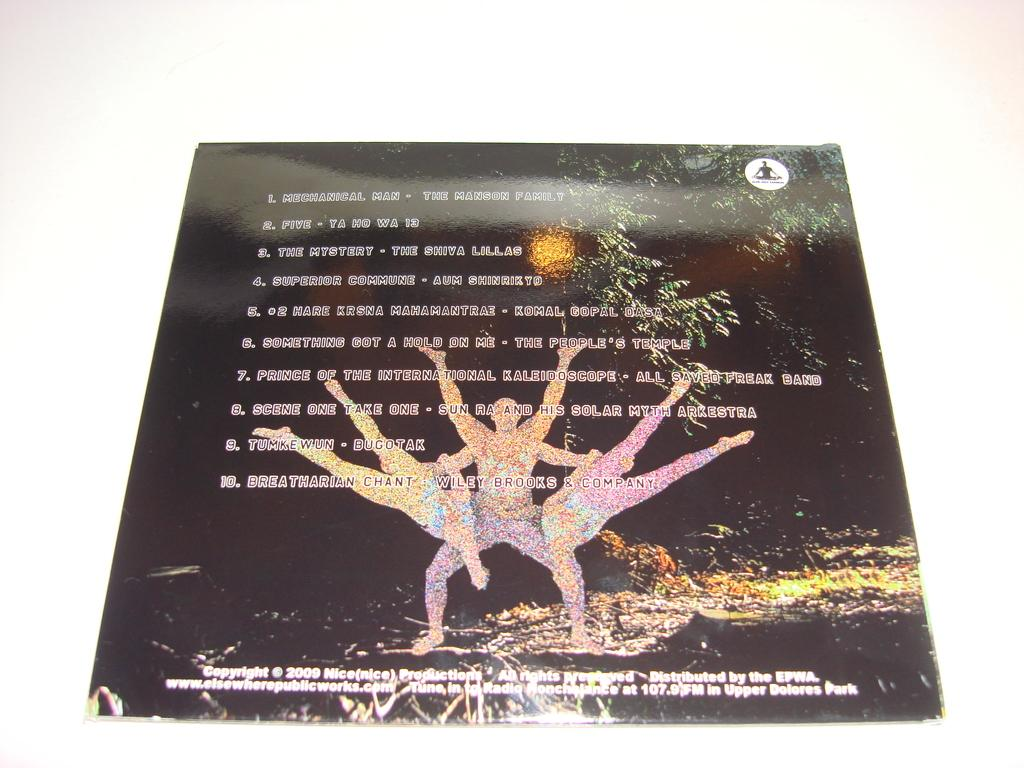What type of visual is depicted in the image? The image appears to be a poster. What elements are included on the poster? The poster contains pictures, text, and a logo. What can be seen on the white surface in the background of the image? There is a white surface in the background of the image. Can you tell me how many firemen are rewarded in the image? There is no mention of firemen or rewards in the image; it is a poster containing pictures, text, and a logo on a white surface. 